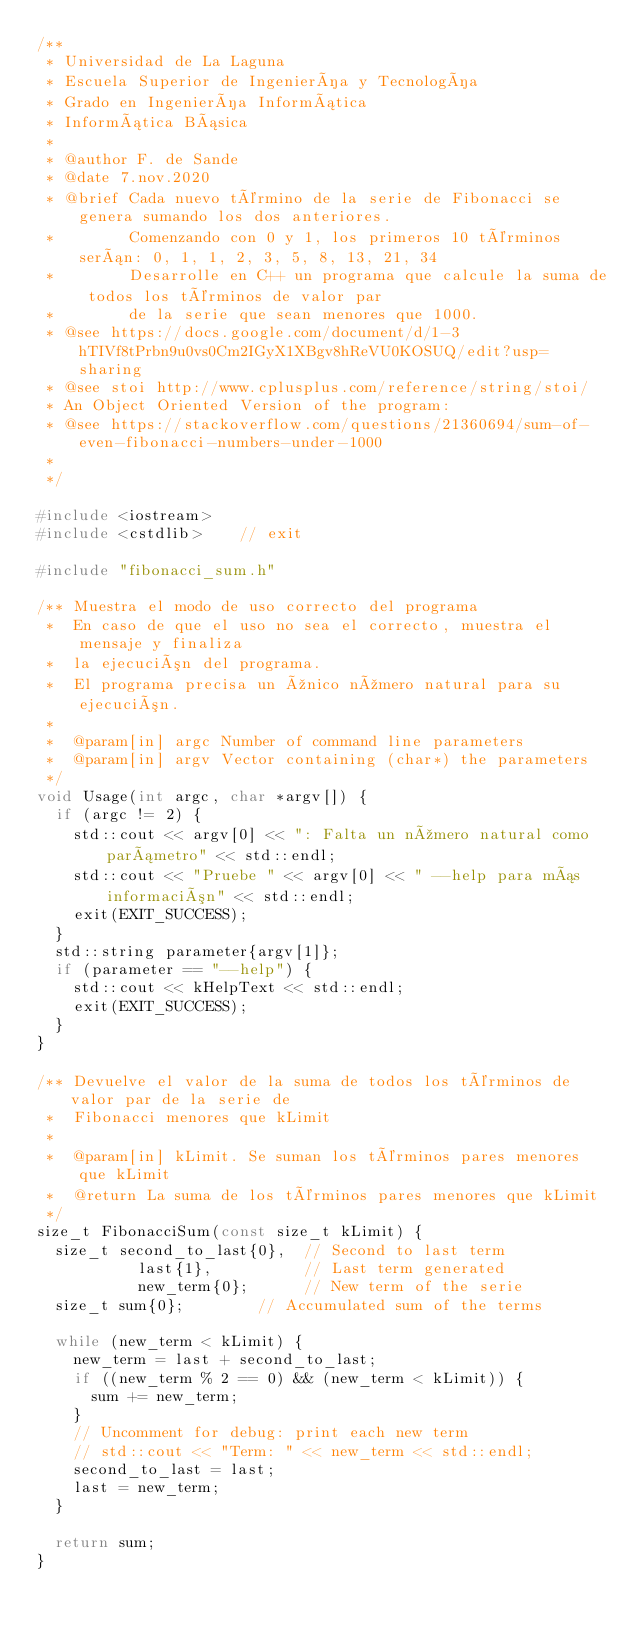Convert code to text. <code><loc_0><loc_0><loc_500><loc_500><_C++_>/**
 * Universidad de La Laguna
 * Escuela Superior de Ingeniería y Tecnología
 * Grado en Ingeniería Informática
 * Informática Básica
 *
 * @author F. de Sande
 * @date 7.nov.2020
 * @brief Cada nuevo término de la serie de Fibonacci se genera sumando los dos anteriores. 
 *        Comenzando con 0 y 1, los primeros 10 términos serán: 0, 1, 1, 2, 3, 5, 8, 13, 21, 34
 *        Desarrolle en C++ un programa que calcule la suma de todos los términos de valor par 
 *        de la serie que sean menores que 1000.
 * @see https://docs.google.com/document/d/1-3hTIVf8tPrbn9u0vs0Cm2IGyX1XBgv8hReVU0KOSUQ/edit?usp=sharing
 * @see stoi http://www.cplusplus.com/reference/string/stoi/
 * An Object Oriented Version of the program:
 * @see https://stackoverflow.com/questions/21360694/sum-of-even-fibonacci-numbers-under-1000
 *
 */

#include <iostream>
#include <cstdlib>    // exit

#include "fibonacci_sum.h"    

/** Muestra el modo de uso correcto del programa
 *  En caso de que el uso no sea el correcto, muestra el mensaje y finaliza
 *  la ejecución del programa.
 *  El programa precisa un único número natural para su ejecución.
 *
 *  @param[in] argc Number of command line parameters
 *  @param[in] argv Vector containing (char*) the parameters
 */
void Usage(int argc, char *argv[]) {
  if (argc != 2) {
    std::cout << argv[0] << ": Falta un número natural como parámetro" << std::endl;
    std::cout << "Pruebe " << argv[0] << " --help para más información" << std::endl;
    exit(EXIT_SUCCESS);
  }
  std::string parameter{argv[1]};
  if (parameter == "--help") {
    std::cout << kHelpText << std::endl;
    exit(EXIT_SUCCESS);
  }
}

/** Devuelve el valor de la suma de todos los términos de valor par de la serie de
 *  Fibonacci menores que kLimit
 *
 *  @param[in] kLimit. Se suman los términos pares menores que kLimit
 *  @return La suma de los términos pares menores que kLimit
 */
size_t FibonacciSum(const size_t kLimit) {
  size_t second_to_last{0},  // Second to last term
           last{1},          // Last term generated
           new_term{0};      // New term of the serie
  size_t sum{0};        // Accumulated sum of the terms

	while (new_term < kLimit) {
    new_term = last + second_to_last;
    if ((new_term % 2 == 0) && (new_term < kLimit)) {
      sum += new_term;
    }
    // Uncomment for debug: print each new term
    // std::cout << "Term: " << new_term << std::endl;
    second_to_last = last;
    last = new_term;
	}

  return sum;
}
</code> 